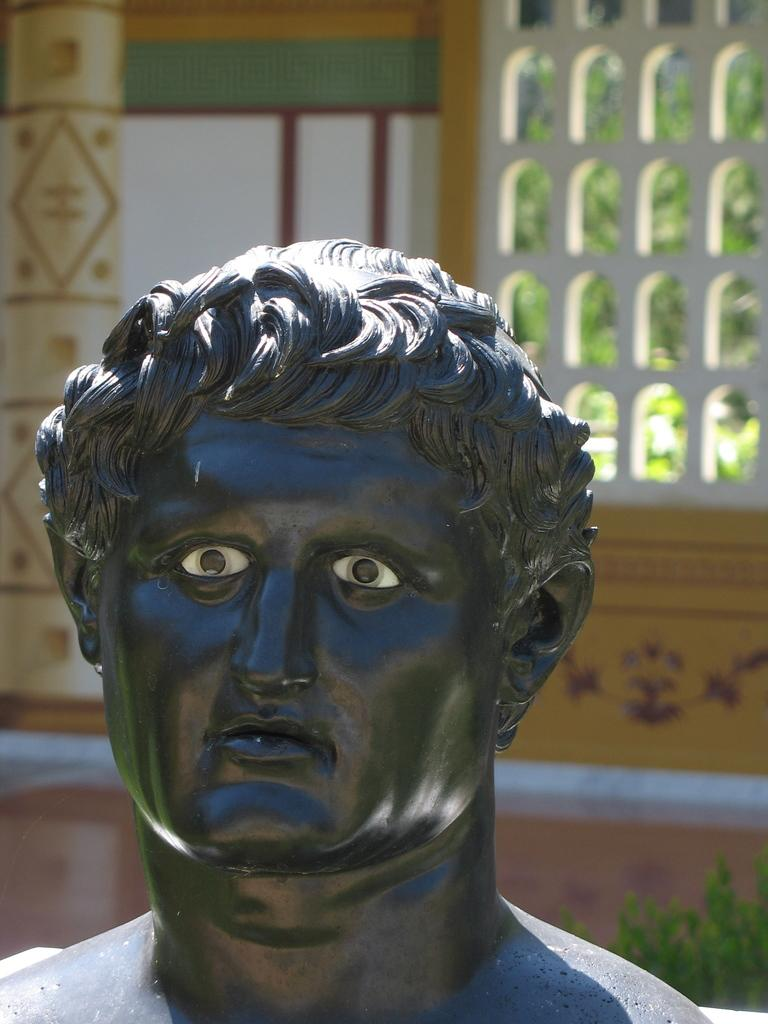What is the main subject of the image? There is a sculpture of a person in the image. What can be seen in the background of the image? There is a designed wall and green leaves in the background of the image. Is there any architectural feature visible in the background? Yes, there is a window in the background of the image. What direction does the society face in the image? There is no society present in the image, only a sculpture of a person. How many steps are visible in the image? There are no steps visible in the image. 